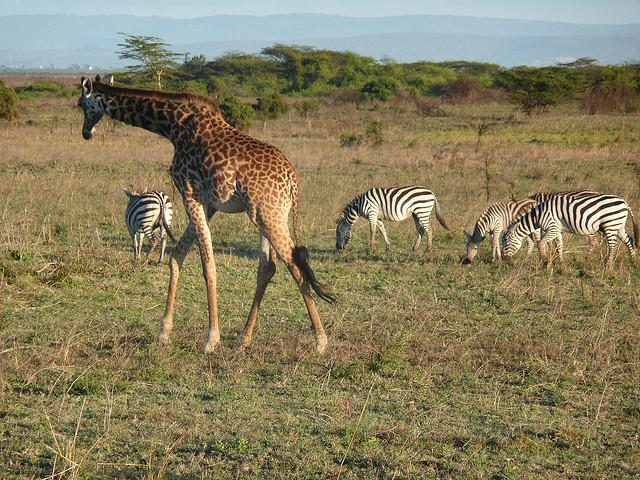What region is this most likely? africa 